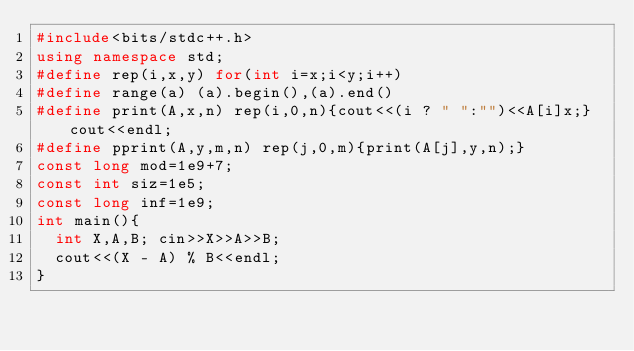<code> <loc_0><loc_0><loc_500><loc_500><_C++_>#include<bits/stdc++.h>
using namespace std;
#define rep(i,x,y) for(int i=x;i<y;i++)
#define range(a) (a).begin(),(a).end()
#define print(A,x,n) rep(i,0,n){cout<<(i ? " ":"")<<A[i]x;}cout<<endl;
#define pprint(A,y,m,n) rep(j,0,m){print(A[j],y,n);}
const long mod=1e9+7;
const int siz=1e5;
const long inf=1e9;
int main(){
	int X,A,B; cin>>X>>A>>B;
	cout<<(X - A) % B<<endl;
}</code> 